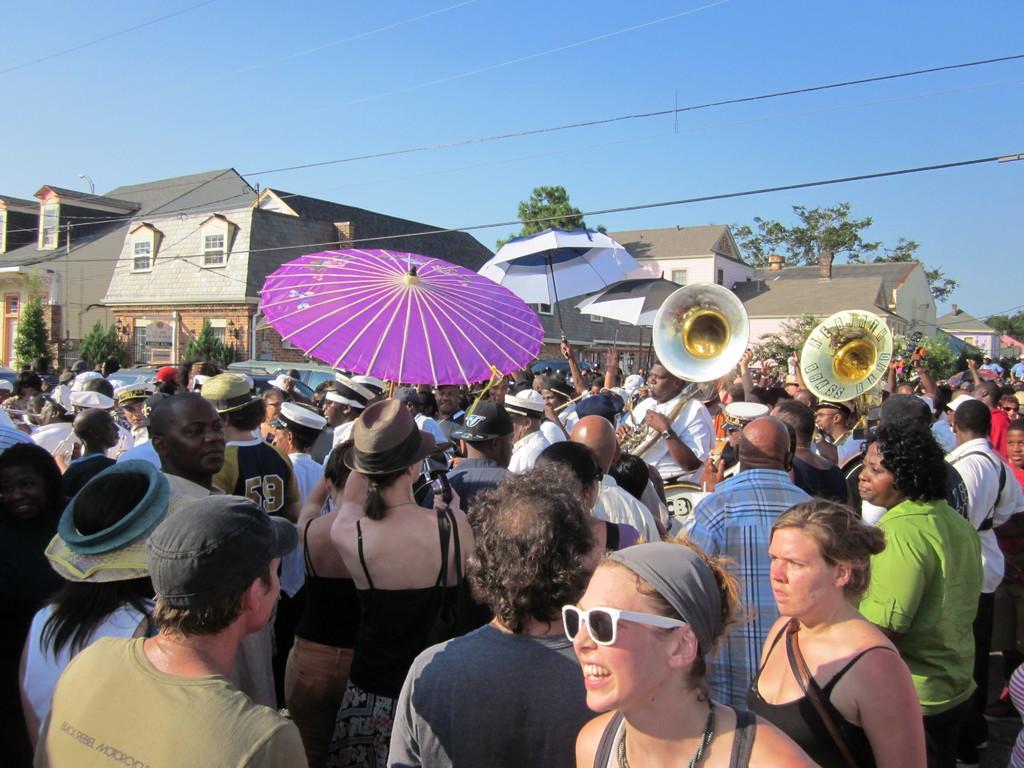In one or two sentences, can you explain what this image depicts? In this picture we can observe an umbrella which is in violet color. There are some people standing on the road. We can observe men and women. There are two musical instruments. In the background there are houses, trees and sky. 